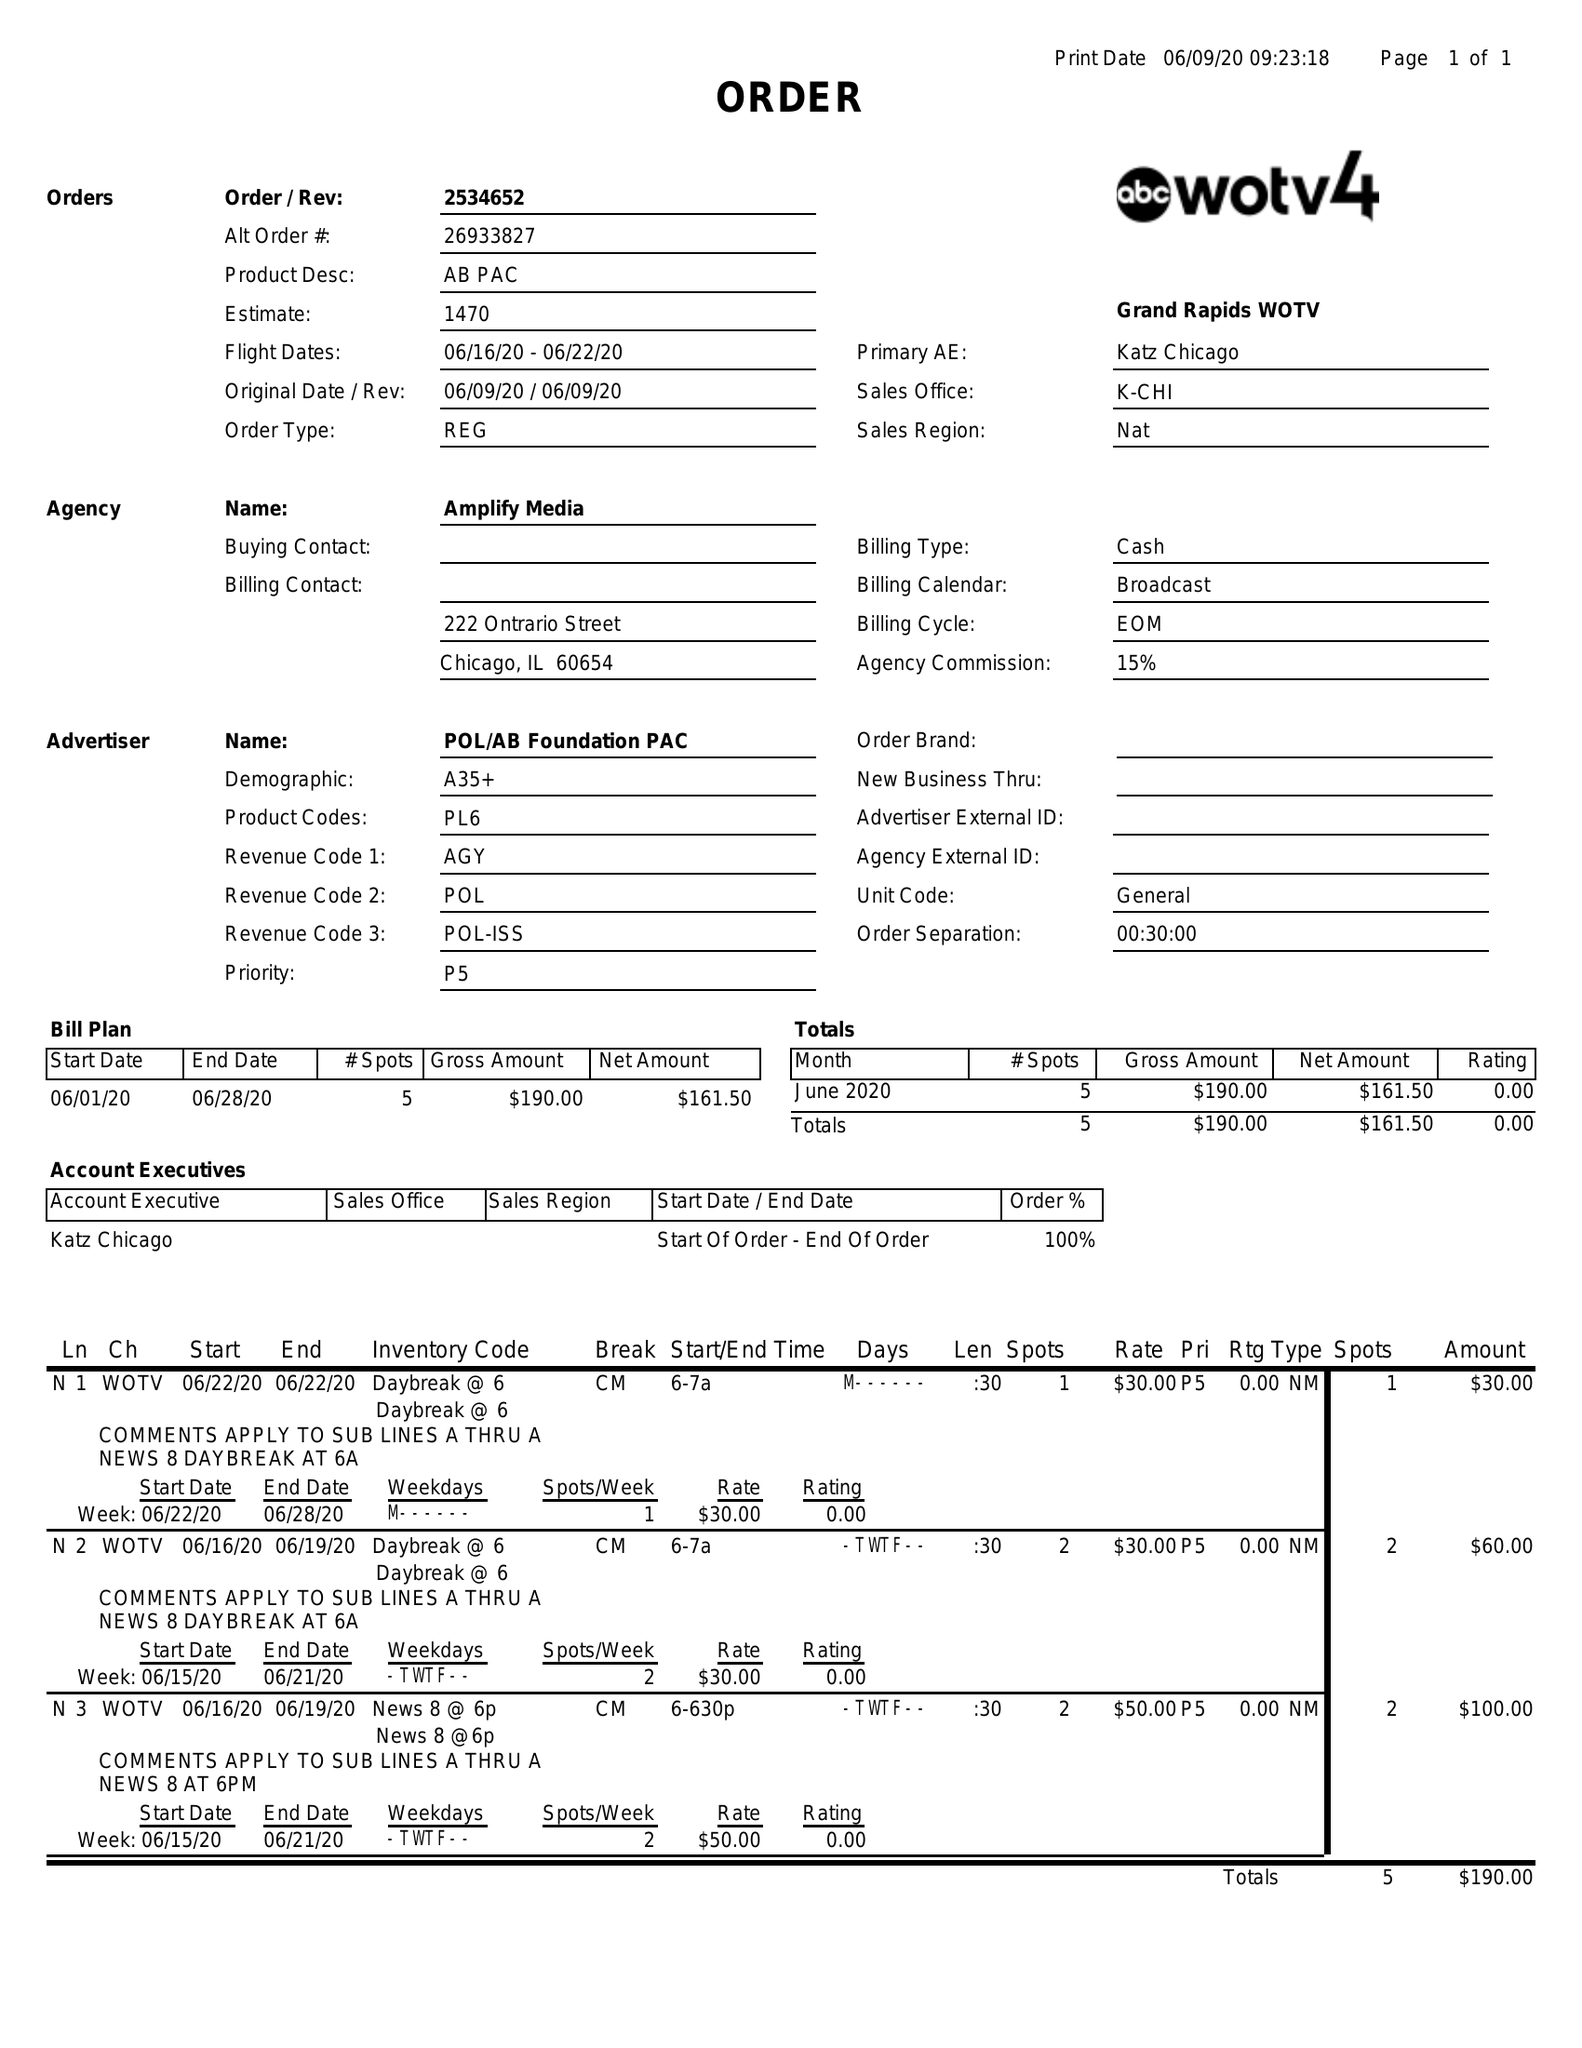What is the value for the gross_amount?
Answer the question using a single word or phrase. 190.00 